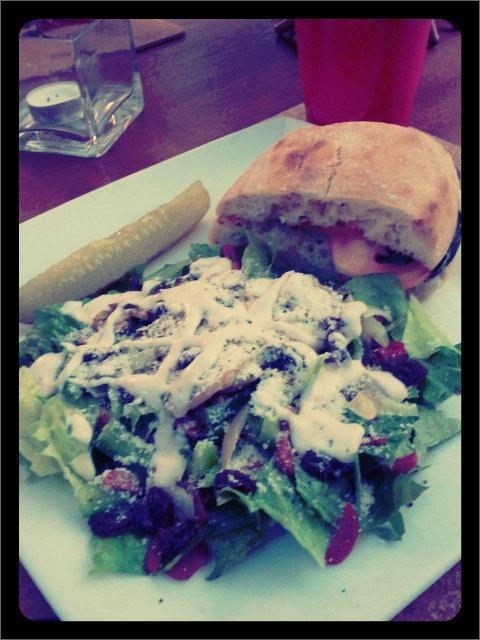What shape is the pickle cut in?
Indicate the correct response by choosing from the four available options to answer the question.
Options: Spear, chunks, sliced, cubed. Spear. 